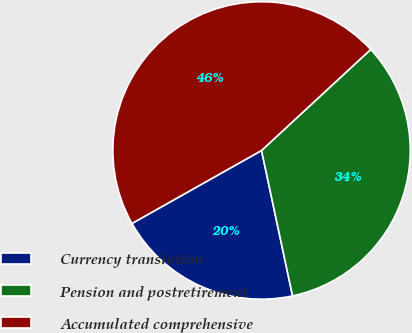Convert chart to OTSL. <chart><loc_0><loc_0><loc_500><loc_500><pie_chart><fcel>Currency translation<fcel>Pension and postretirement<fcel>Accumulated comprehensive<nl><fcel>20.18%<fcel>33.54%<fcel>46.28%<nl></chart> 